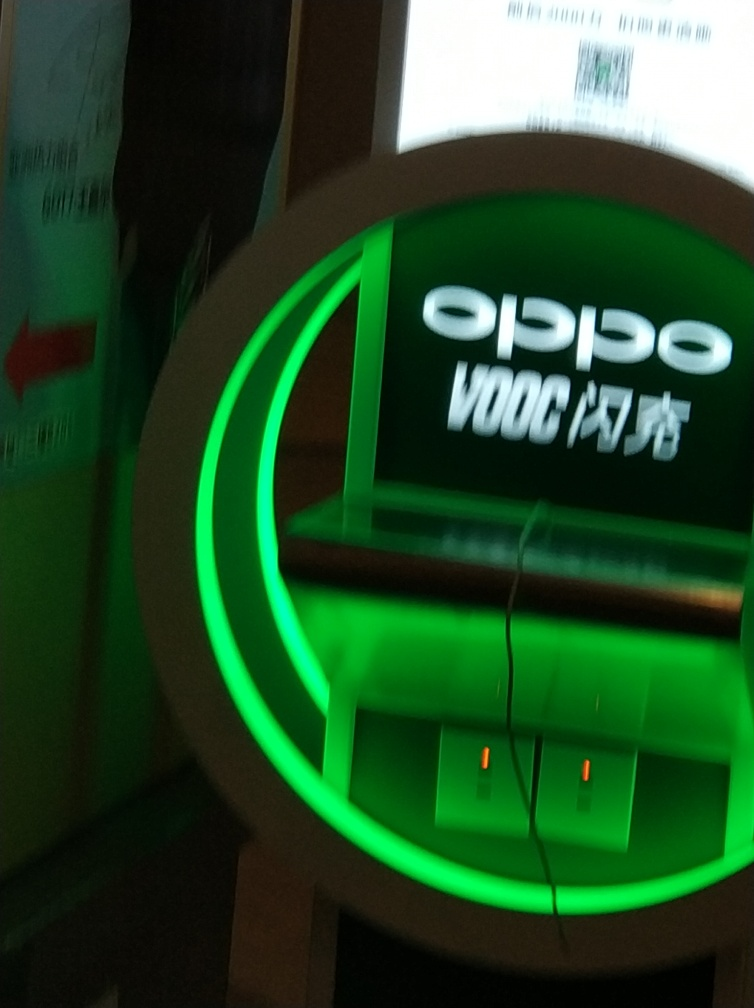With the information given, what do you think this device is used for? Based on the image, this device appears to be a charging kiosk designed for recharging electronic devices, likely smartphones given the brand displayed. It provides a convenient way for users to quickly boost their battery life while away from traditional power sources. What makes you believe that this is a quick charging station specifically for that brand? The branding, which includes the term 'VOOC', indicates a specific type of fast charging technology that's proprietary to a particular electronics manufacturer. This suggests that the charging station is designed to complement devices from that brand, offering a rapid charge feature that's optimized for their products. 